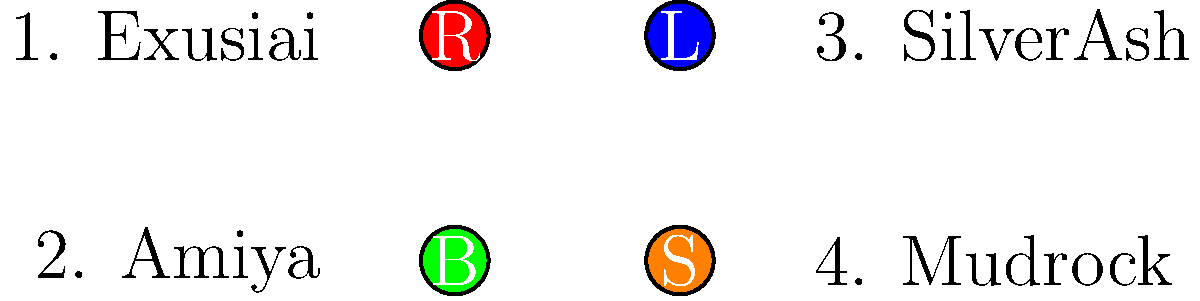Match the Arknights operators to their corresponding faction logos:

1. Exusiai
2. Amiya
3. SilverAsh
4. Mudrock

R: Rhodes Island
L: Lungmen Guard Department
B: Babel
S: Sarkaz To match the Arknights operators to their correct faction logos, we need to consider their backgrounds and affiliations:

1. Exusiai: She is a Sankta from Laterano but works as a messenger for Penguin Logistics, which is closely associated with Rhodes Island. Therefore, Exusiai corresponds to the R (Rhodes Island) logo.

2. Amiya: As the leader of Rhodes Island and a key figure in the main storyline, Amiya is strongly connected to both Rhodes Island and Babel. However, her deeper ties and origin are with Babel. Thus, Amiya corresponds to the B (Babel) logo.

3. SilverAsh: He is the head of the Silverash family and the leader of Kjerag. While he collaborates with Rhodes Island, he is not directly affiliated with any of the given factions. However, his interactions often involve Lungmen, so he best corresponds to the L (Lungmen Guard Department) logo.

4. Mudrock: She is a Sarkaz operator who initially opposed Rhodes Island but later joined them. Due to her Sarkaz heritage, Mudrock corresponds to the S (Sarkaz) logo.
Answer: 1-R, 2-B, 3-L, 4-S 